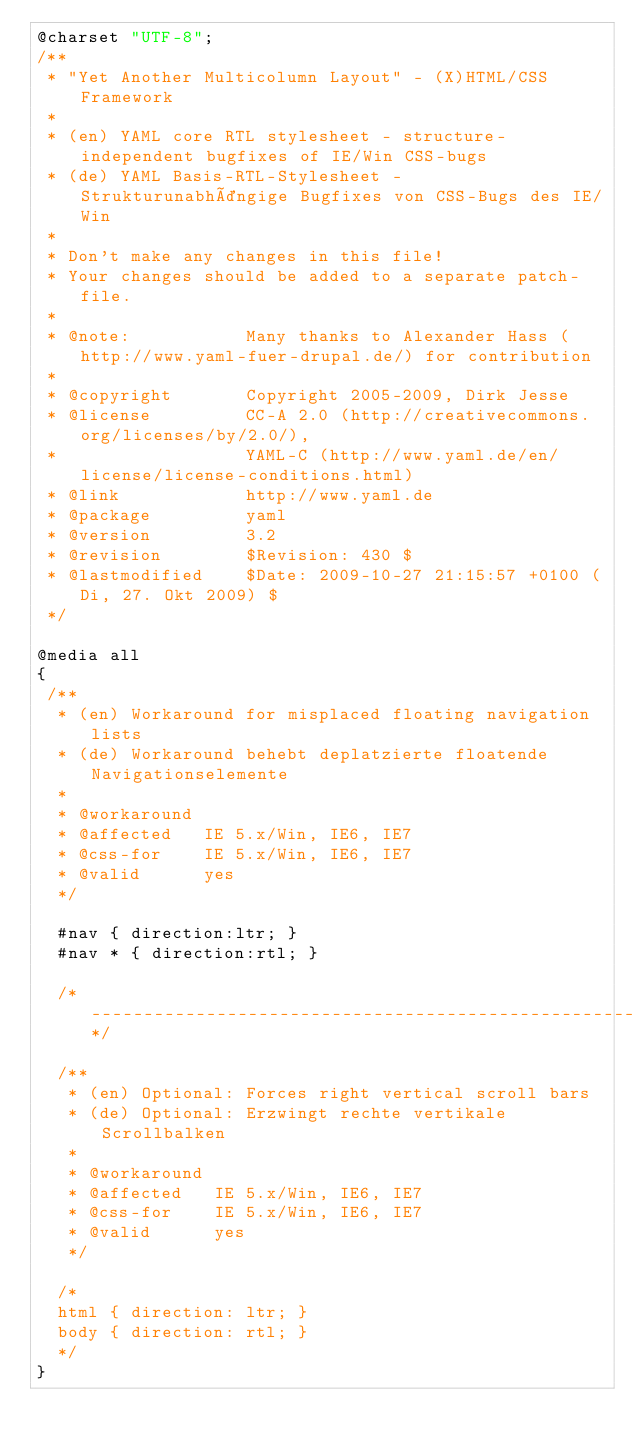Convert code to text. <code><loc_0><loc_0><loc_500><loc_500><_CSS_>@charset "UTF-8";
/**
 * "Yet Another Multicolumn Layout" - (X)HTML/CSS Framework
 *
 * (en) YAML core RTL stylesheet - structure-independent bugfixes of IE/Win CSS-bugs
 * (de) YAML Basis-RTL-Stylesheet - Strukturunabhängige Bugfixes von CSS-Bugs des IE/Win
 *
 * Don't make any changes in this file!
 * Your changes should be added to a separate patch-file.
 *
 * @note:           Many thanks to Alexander Hass (http://www.yaml-fuer-drupal.de/) for contribution
 *
 * @copyright       Copyright 2005-2009, Dirk Jesse
 * @license         CC-A 2.0 (http://creativecommons.org/licenses/by/2.0/),
 *                  YAML-C (http://www.yaml.de/en/license/license-conditions.html)
 * @link            http://www.yaml.de
 * @package         yaml
 * @version         3.2
 * @revision        $Revision: 430 $
 * @lastmodified    $Date: 2009-10-27 21:15:57 +0100 (Di, 27. Okt 2009) $
 */

@media all
{
 /**
  * (en) Workaround for misplaced floating navigation lists
  * (de) Workaround behebt deplatzierte floatende Navigationselemente
  *
  * @workaround
  * @affected   IE 5.x/Win, IE6, IE7
  * @css-for    IE 5.x/Win, IE6, IE7
  * @valid      yes
  */

  #nav { direction:ltr; }
  #nav * { direction:rtl; }

  /*------------------------------------------------------------------------------------------------------*/

  /**
   * (en) Optional: Forces right vertical scroll bars
   * (de) Optional: Erzwingt rechte vertikale Scrollbalken
   *
   * @workaround
   * @affected   IE 5.x/Win, IE6, IE7
   * @css-for    IE 5.x/Win, IE6, IE7
   * @valid      yes
   */

  /*
  html { direction: ltr; }
  body { direction: rtl; }
  */
}
</code> 